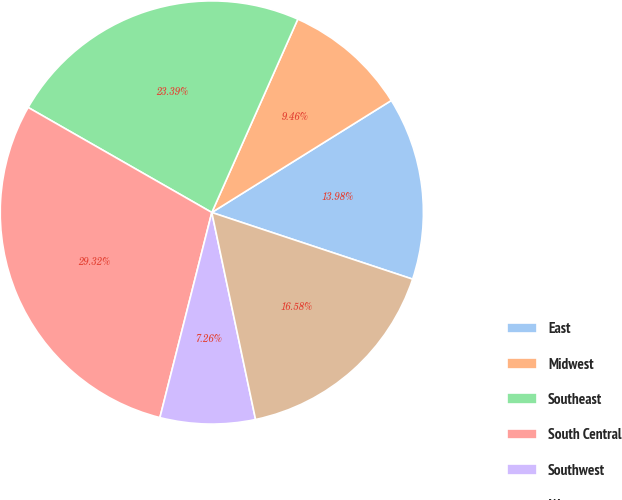<chart> <loc_0><loc_0><loc_500><loc_500><pie_chart><fcel>East<fcel>Midwest<fcel>Southeast<fcel>South Central<fcel>Southwest<fcel>West<nl><fcel>13.98%<fcel>9.46%<fcel>23.39%<fcel>29.32%<fcel>7.26%<fcel>16.58%<nl></chart> 